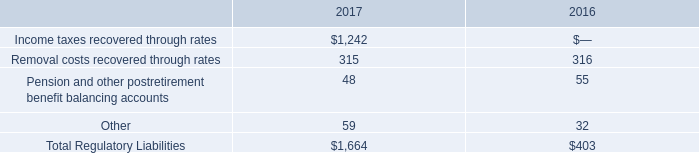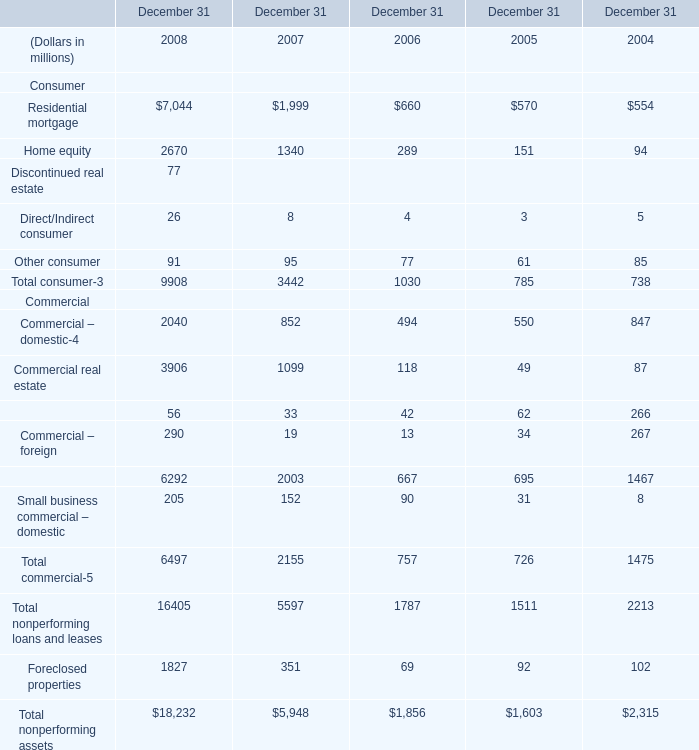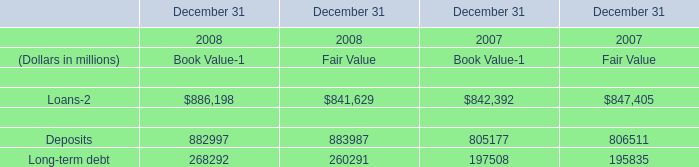What's the average of the Commercial real estate for Commercial in the years where Deposits for Fair Value is positive? (in million) 
Computations: ((3906 + 1099) / 2)
Answer: 2502.5. 